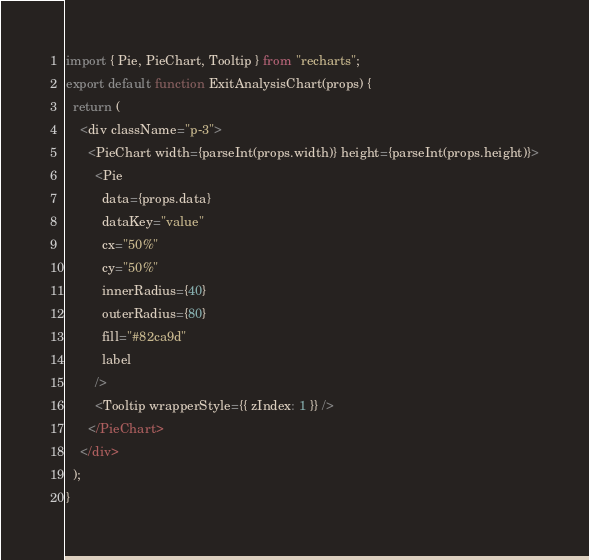<code> <loc_0><loc_0><loc_500><loc_500><_JavaScript_>import { Pie, PieChart, Tooltip } from "recharts";
export default function ExitAnalysisChart(props) {
  return (
    <div className="p-3">
      <PieChart width={parseInt(props.width)} height={parseInt(props.height)}>
        <Pie
          data={props.data}
          dataKey="value"
          cx="50%"
          cy="50%"
          innerRadius={40}
          outerRadius={80}
          fill="#82ca9d"
          label
        />
        <Tooltip wrapperStyle={{ zIndex: 1 }} />
      </PieChart>
    </div>
  );
}
</code> 